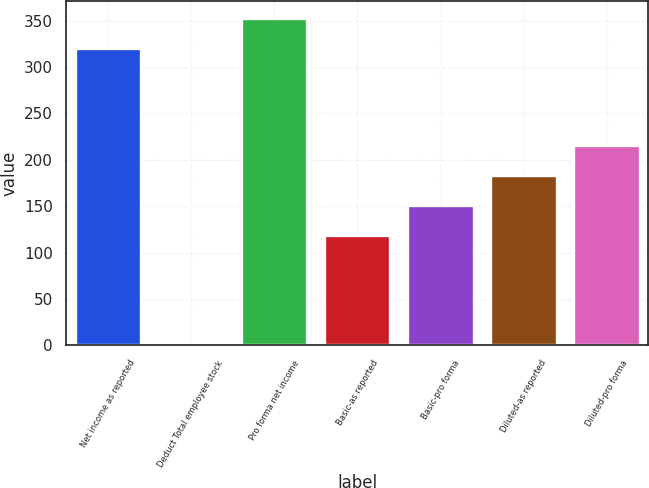<chart> <loc_0><loc_0><loc_500><loc_500><bar_chart><fcel>Net income as reported<fcel>Deduct Total employee stock<fcel>Pro forma net income<fcel>Basic-as reported<fcel>Basic-pro forma<fcel>Diluted-as reported<fcel>Diluted-pro forma<nl><fcel>321<fcel>1<fcel>353<fcel>119.5<fcel>151.5<fcel>183.5<fcel>215.5<nl></chart> 